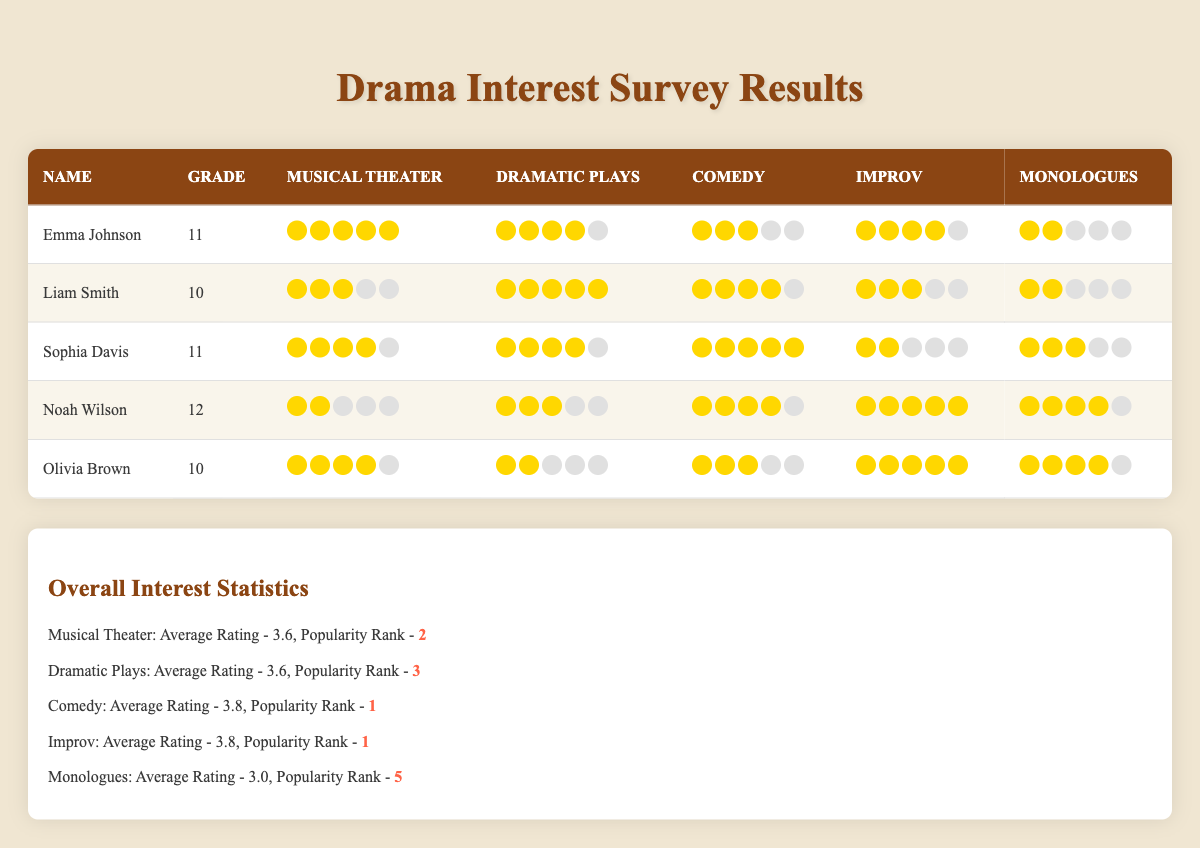What is the average rating for Comedy? The average rating for Comedy is mentioned directly in the overall interest section of the table, which states it is 3.8.
Answer: 3.8 Which student has the highest interest in Improv? By checking the interest ratings in the Improv column, Noah Wilson and Olivia Brown both have a rating of 5, which is the highest among all the students.
Answer: Noah Wilson and Olivia Brown Is there a student who rated Monologues higher than 3? By examining the Monologues ratings in the interests section, none of the students have a rating higher than 3. Thus, this is false.
Answer: No What is the total interest rating for Musical Theater among all students? Summing the ratings for Musical Theater: Emma (5) + Liam (3) + Sophia (4) + Noah (2) + Olivia (4) = 18.
Answer: 18 Who has a higher interest in Comedy: Liam Smith or Emma Johnson? Liam Smith has a rating of 4 for Comedy, while Emma Johnson has a rating of 3. Therefore, Liam Smith has a higher interest.
Answer: Liam Smith Which performance style has the lowest popularity rank, and what is that rank? Looking at the overall interest statistics, Monologues has the lowest popularity rank, which is 5.
Answer: Monologues, 5 How many students rated Dramatic Plays higher than 3? Checking the ratings for Dramatic Plays: Liam (5), Emma (4), Sophia (4) are all higher than 3. Therefore, 3 students rated it higher than 3.
Answer: 3 What is the difference between the average ratings of Improv and Monologues? The average rating of Improv is 3.8, while Monologues has an average rating of 3.0. The difference is calculated as 3.8 - 3.0 = 0.8.
Answer: 0.8 Did any student rate both Musical Theater and Comedy the same? Evaluating the ratings, Emma Johnson rated Musical Theater 5 and Comedy 3, while no other students have the same rating for both. Therefore, the answer is false.
Answer: No 